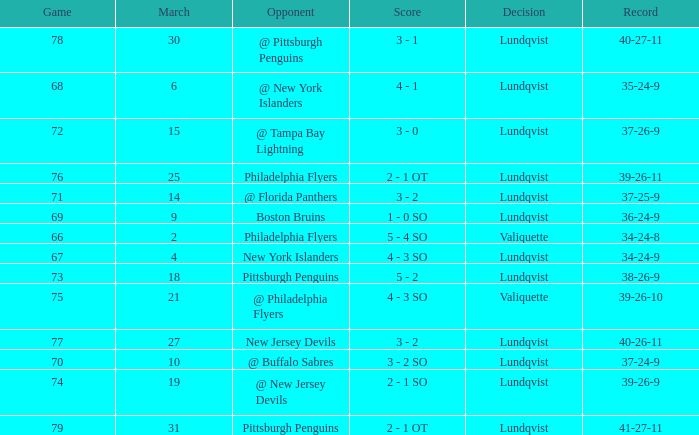Which opponent's game was less than 76 when the march was 10? @ Buffalo Sabres. 